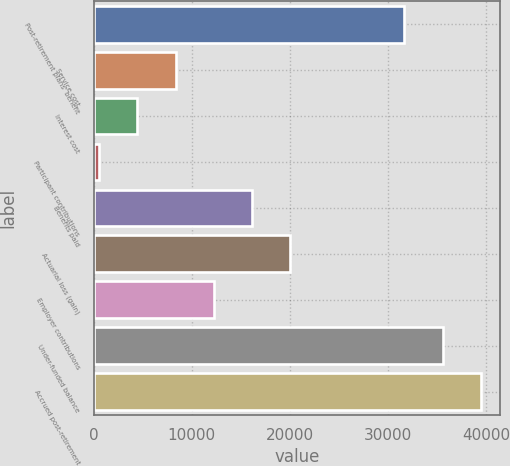Convert chart to OTSL. <chart><loc_0><loc_0><loc_500><loc_500><bar_chart><fcel>Post-retirement plans' benefit<fcel>Service cost<fcel>Interest cost<fcel>Participant contributions<fcel>Benefits paid<fcel>Actuarial loss (gain)<fcel>Employer contributions<fcel>Under-funded balance<fcel>Accrued post-retirement<nl><fcel>31649.8<fcel>8342.2<fcel>4457.6<fcel>573<fcel>16111.4<fcel>19996<fcel>12226.8<fcel>35534.4<fcel>39419<nl></chart> 